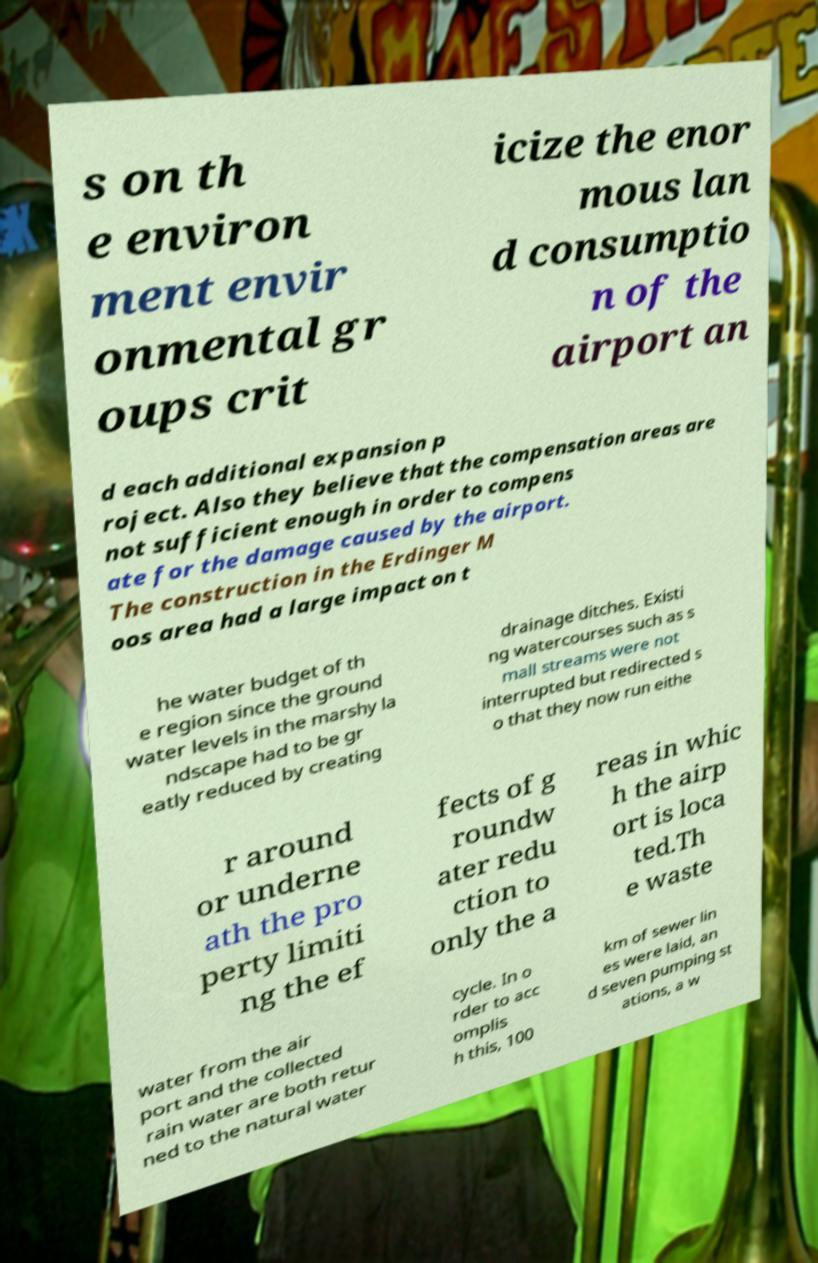Can you read and provide the text displayed in the image?This photo seems to have some interesting text. Can you extract and type it out for me? s on th e environ ment envir onmental gr oups crit icize the enor mous lan d consumptio n of the airport an d each additional expansion p roject. Also they believe that the compensation areas are not sufficient enough in order to compens ate for the damage caused by the airport. The construction in the Erdinger M oos area had a large impact on t he water budget of th e region since the ground water levels in the marshy la ndscape had to be gr eatly reduced by creating drainage ditches. Existi ng watercourses such as s mall streams were not interrupted but redirected s o that they now run eithe r around or underne ath the pro perty limiti ng the ef fects of g roundw ater redu ction to only the a reas in whic h the airp ort is loca ted.Th e waste water from the air port and the collected rain water are both retur ned to the natural water cycle. In o rder to acc omplis h this, 100 km of sewer lin es were laid, an d seven pumping st ations, a w 